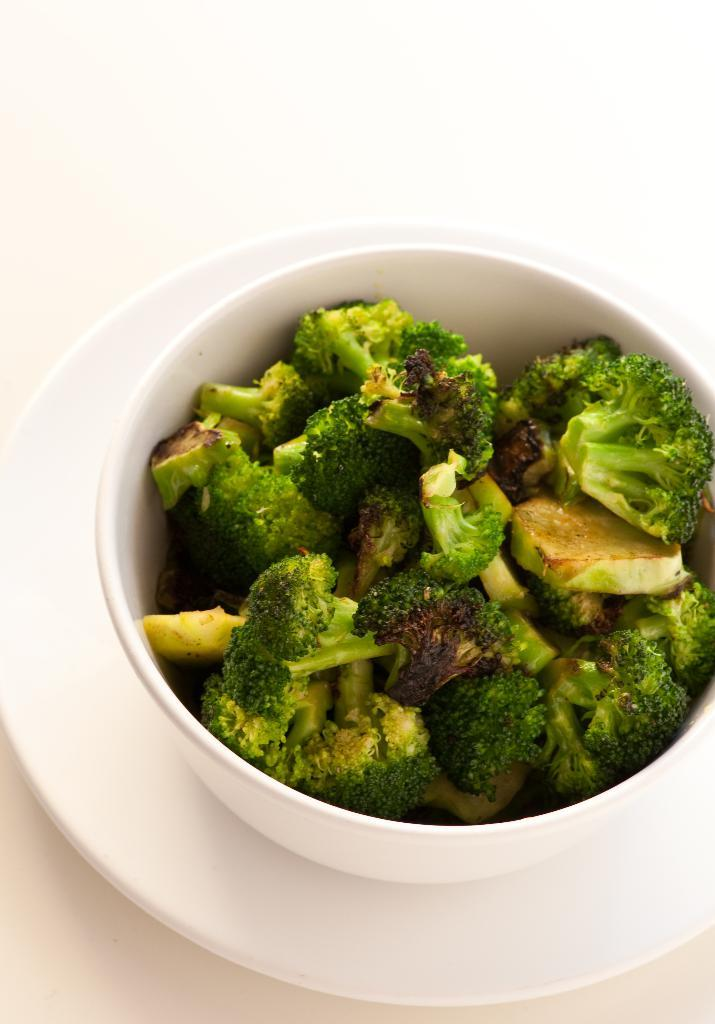What is in the bowl that is visible in the image? There is a bowl with broccoli in the image. What other dishware can be seen in the image? There is a plate in the image. What color is the background of the image? The background of the image is white. What type of silver object can be seen in the image? There is no silver object present in the image. How many circles are visible in the image? There are no circles visible in the image. 